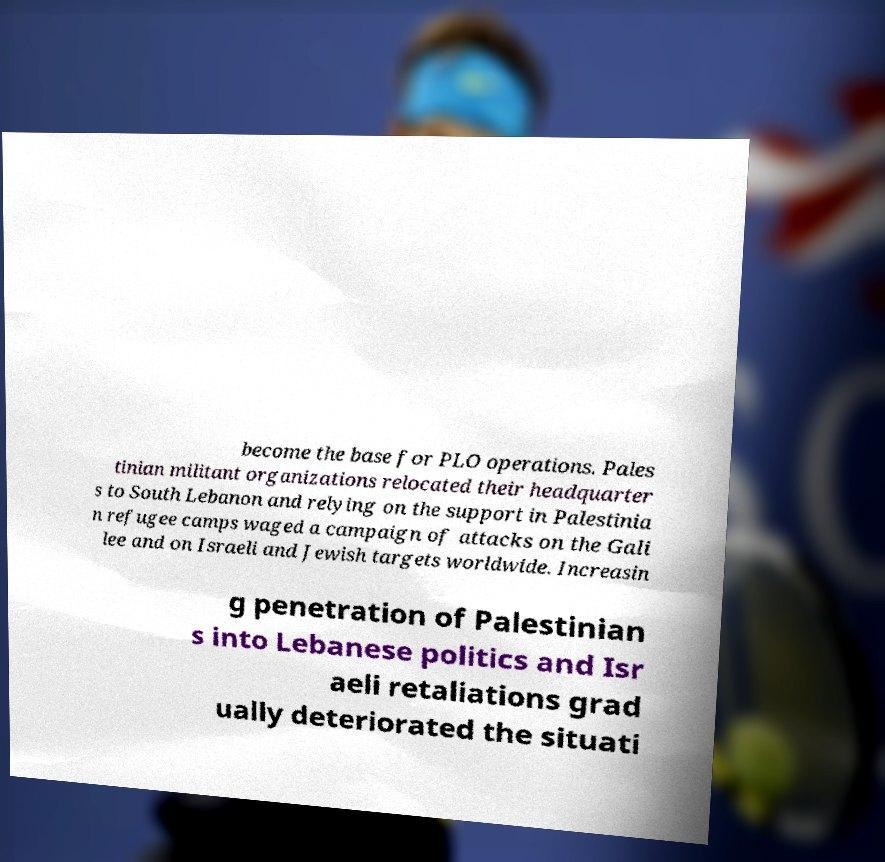Could you assist in decoding the text presented in this image and type it out clearly? become the base for PLO operations. Pales tinian militant organizations relocated their headquarter s to South Lebanon and relying on the support in Palestinia n refugee camps waged a campaign of attacks on the Gali lee and on Israeli and Jewish targets worldwide. Increasin g penetration of Palestinian s into Lebanese politics and Isr aeli retaliations grad ually deteriorated the situati 